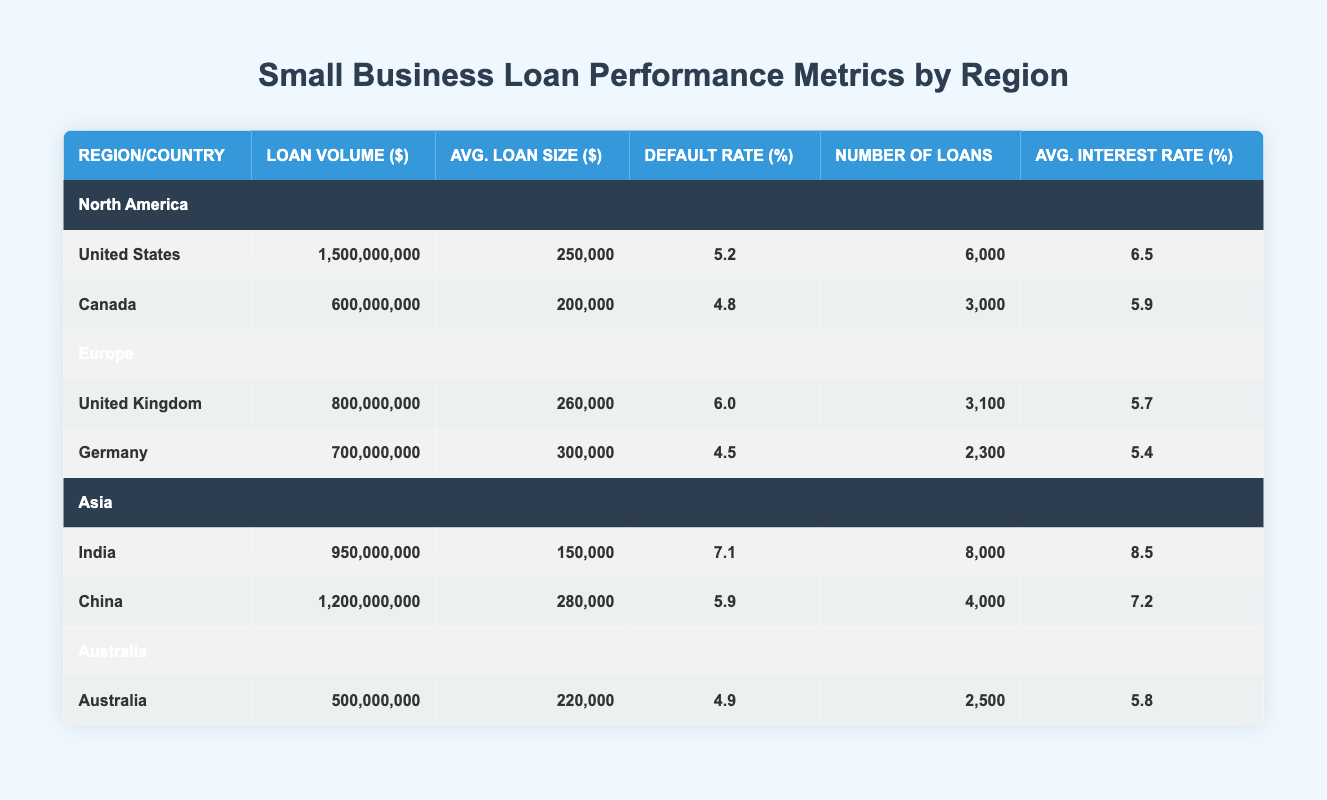What is the total loan volume for North America? The loan volume for North America consists of the United States and Canada. Summing these amounts gives us 1,500,000,000 + 600,000,000 = 2,100,000,000.
Answer: 2,100,000,000 Which country in Europe has the highest average loan size? In Europe, the average loan sizes are 260,000 for the United Kingdom and 300,000 for Germany. Germany has the highest average loan size.
Answer: Germany Is the default rate in China higher than in Canada? The default rate in China is 5.9, and in Canada, it is 4.8. Since 5.9 is greater than 4.8, the statement is true.
Answer: Yes What is the average interest rate for loans in Asia? The average interest rates in Asia are 8.5 for India and 7.2 for China. To find the average, we add these together (8.5 + 7.2 = 15.7) and then divide by 2, giving us 15.7 / 2 = 7.85.
Answer: 7.85 How many loans were issued in the United States compared to Germany? The number of loans in the United States is 6,000, while in Germany, it is 2,300. The United States has more loans issued because 6,000 is greater than 2,300.
Answer: More in the United States Which region has the lowest default rate among all countries? The default rates are 5.2 (United States), 4.8 (Canada), 6.0 (United Kingdom), 4.5 (Germany), 7.1 (India), 5.9 (China), and 4.9 (Australia). The lowest is 4.5 in Germany.
Answer: Germany What is the total number of loans across all regions? The total number of loans can be calculated by summing all countries: 6,000 (USA) + 3,000 (Canada) + 3,100 (UK) + 2,300 (Germany) + 8,000 (India) + 4,000 (China) + 2,500 (Australia) = 28,900.
Answer: 28,900 Is Australia’s average loan size higher than the average loan size in the United States? The average loan size in Australia is 220,000, while in the United States, it is 250,000. Since 220,000 is less than 250,000, the statement is false.
Answer: No What is the difference in loan volume between India and Germany? The loan volume for India is 950,000,000 and for Germany is 700,000,000. The difference is calculated as 950,000,000 - 700,000,000 = 250,000,000.
Answer: 250,000,000 